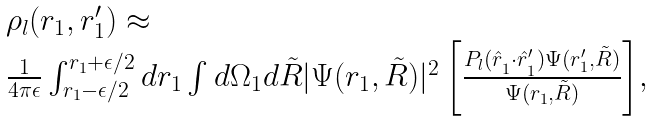<formula> <loc_0><loc_0><loc_500><loc_500>\begin{array} { l } \rho _ { l } ( r _ { 1 } , r _ { 1 } ^ { \prime } ) \approx \\ \frac { 1 } { 4 \pi \epsilon } \int _ { r _ { 1 } - \epsilon / 2 } ^ { r _ { 1 } + \epsilon / 2 } { d r _ { 1 } \int d \Omega _ { 1 } d { \tilde { R } } | \Psi ( { r } _ { 1 } , { \tilde { R } } ) | ^ { 2 } \left [ \frac { P _ { l } ( \hat { r } _ { _ { 1 } } \cdot \hat { r } ^ { \prime } _ { _ { 1 } } ) \Psi ( { r } _ { 1 } ^ { \prime } , { \tilde { R } } ) } { \Psi ( { r } _ { 1 } , { \tilde { R } } ) } \right ] } , \end{array}</formula> 